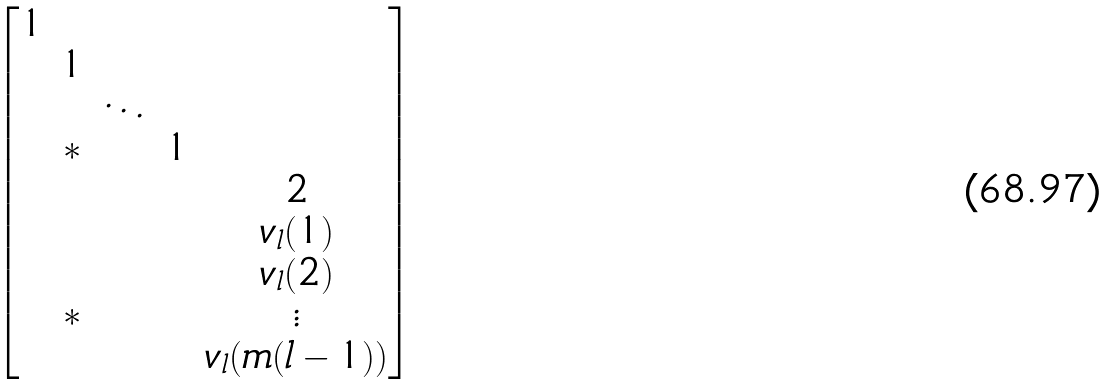Convert formula to latex. <formula><loc_0><loc_0><loc_500><loc_500>\begin{bmatrix} 1 & & & & \\ & 1 & & & \\ & & \ddots & & \\ & * & & 1 & \\ & & & & 2 \\ & & & & v _ { l } ( 1 ) \\ & & & & v _ { l } ( 2 ) \\ & * & & & \vdots \\ & & & & v _ { l } ( m ( l - 1 ) ) \end{bmatrix}</formula> 